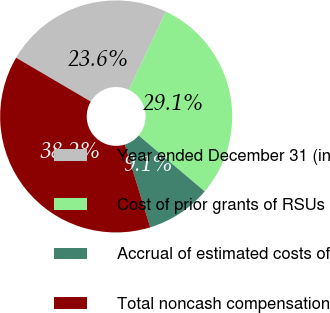Convert chart to OTSL. <chart><loc_0><loc_0><loc_500><loc_500><pie_chart><fcel>Year ended December 31 (in<fcel>Cost of prior grants of RSUs<fcel>Accrual of estimated costs of<fcel>Total noncash compensation<nl><fcel>23.61%<fcel>29.12%<fcel>9.07%<fcel>38.19%<nl></chart> 